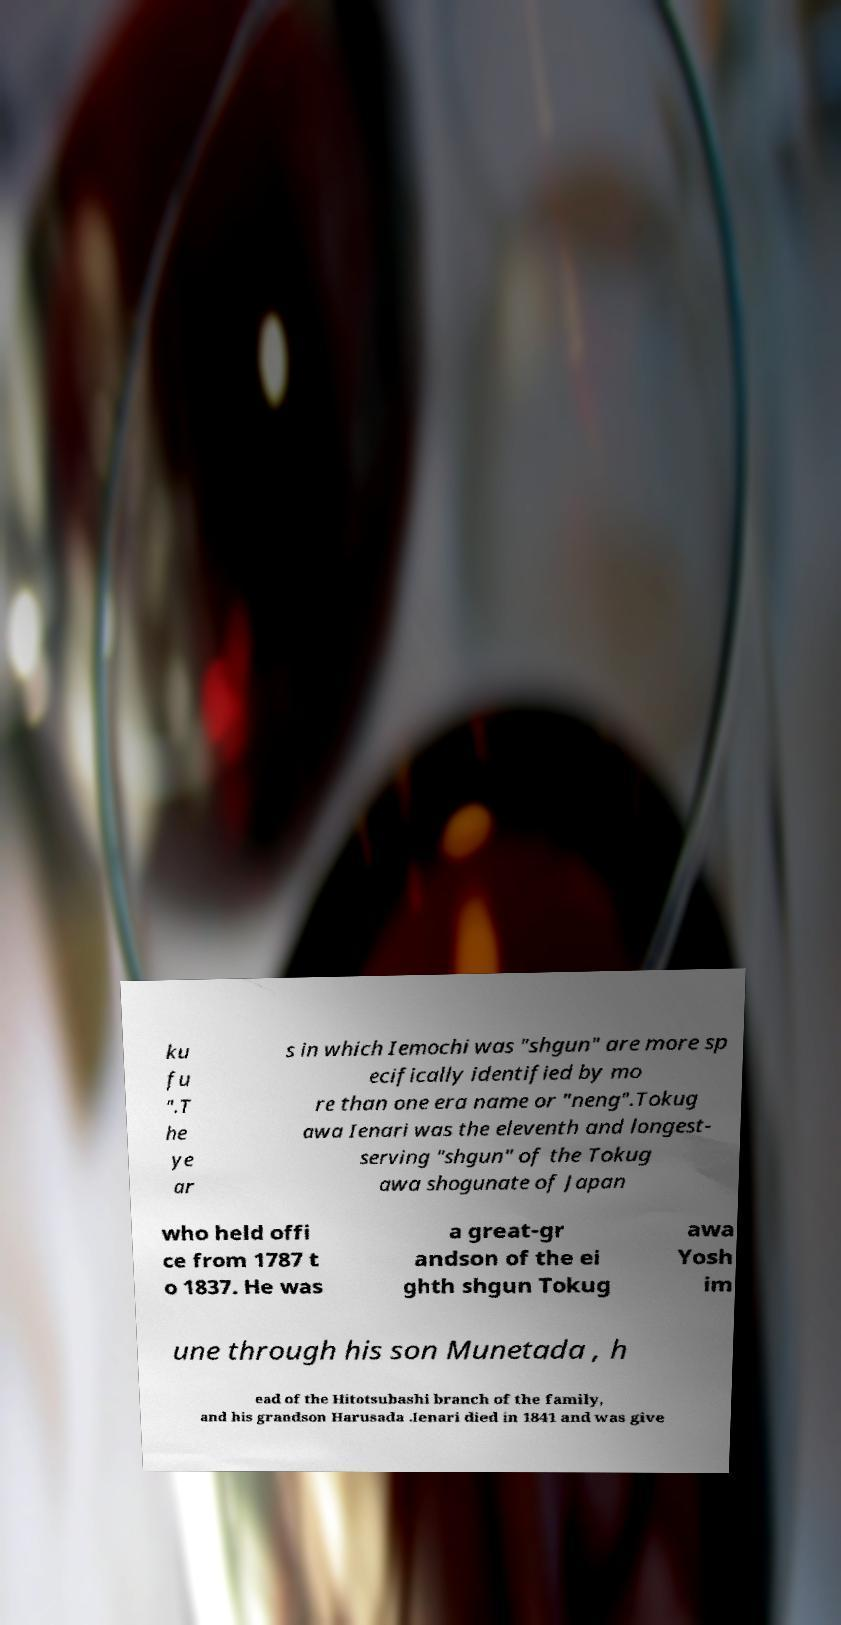Please read and relay the text visible in this image. What does it say? ku fu ".T he ye ar s in which Iemochi was "shgun" are more sp ecifically identified by mo re than one era name or "neng".Tokug awa Ienari was the eleventh and longest- serving "shgun" of the Tokug awa shogunate of Japan who held offi ce from 1787 t o 1837. He was a great-gr andson of the ei ghth shgun Tokug awa Yosh im une through his son Munetada , h ead of the Hitotsubashi branch of the family, and his grandson Harusada .Ienari died in 1841 and was give 